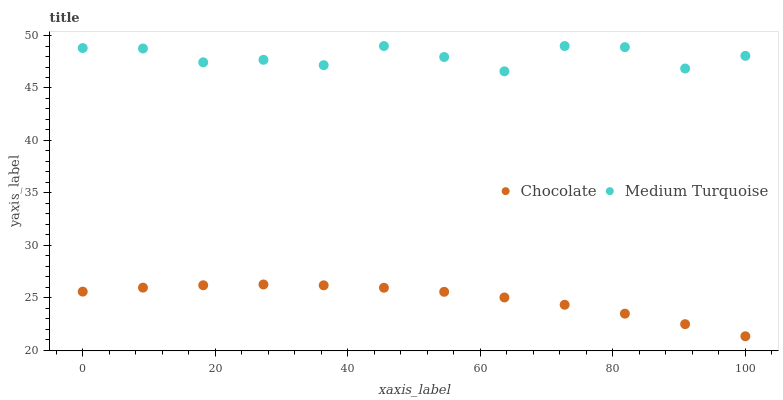Does Chocolate have the minimum area under the curve?
Answer yes or no. Yes. Does Medium Turquoise have the maximum area under the curve?
Answer yes or no. Yes. Does Chocolate have the maximum area under the curve?
Answer yes or no. No. Is Chocolate the smoothest?
Answer yes or no. Yes. Is Medium Turquoise the roughest?
Answer yes or no. Yes. Is Chocolate the roughest?
Answer yes or no. No. Does Chocolate have the lowest value?
Answer yes or no. Yes. Does Medium Turquoise have the highest value?
Answer yes or no. Yes. Does Chocolate have the highest value?
Answer yes or no. No. Is Chocolate less than Medium Turquoise?
Answer yes or no. Yes. Is Medium Turquoise greater than Chocolate?
Answer yes or no. Yes. Does Chocolate intersect Medium Turquoise?
Answer yes or no. No. 